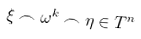Convert formula to latex. <formula><loc_0><loc_0><loc_500><loc_500>\xi \frown \omega ^ { k } \frown \eta \in T ^ { n }</formula> 